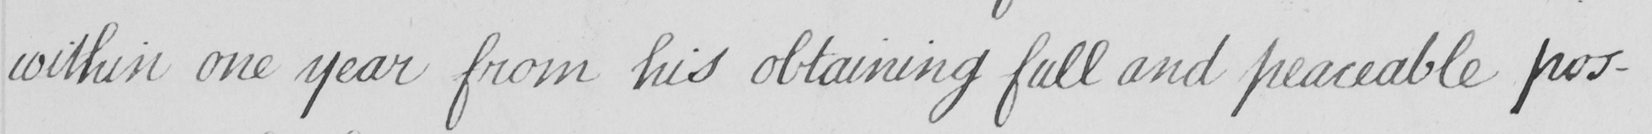What is written in this line of handwriting? within one year from his obtaining full and peaceable pos- 